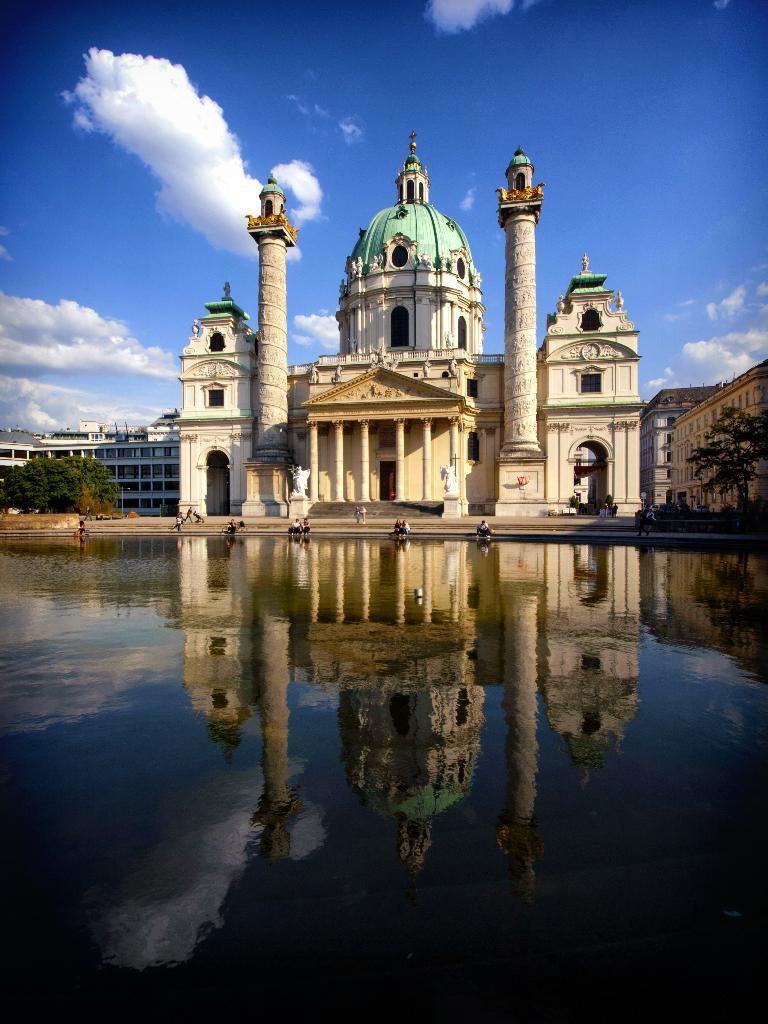Could you give a brief overview of what you see in this image? At the bottom of the picture, we see water and this water might be in the river. Behind that, we see people are sitting. Behind that, we see a church or a monument. On the right side, we see trees and buildings. There are trees and buildings in the background. At the top, we see the sky and the clouds. 